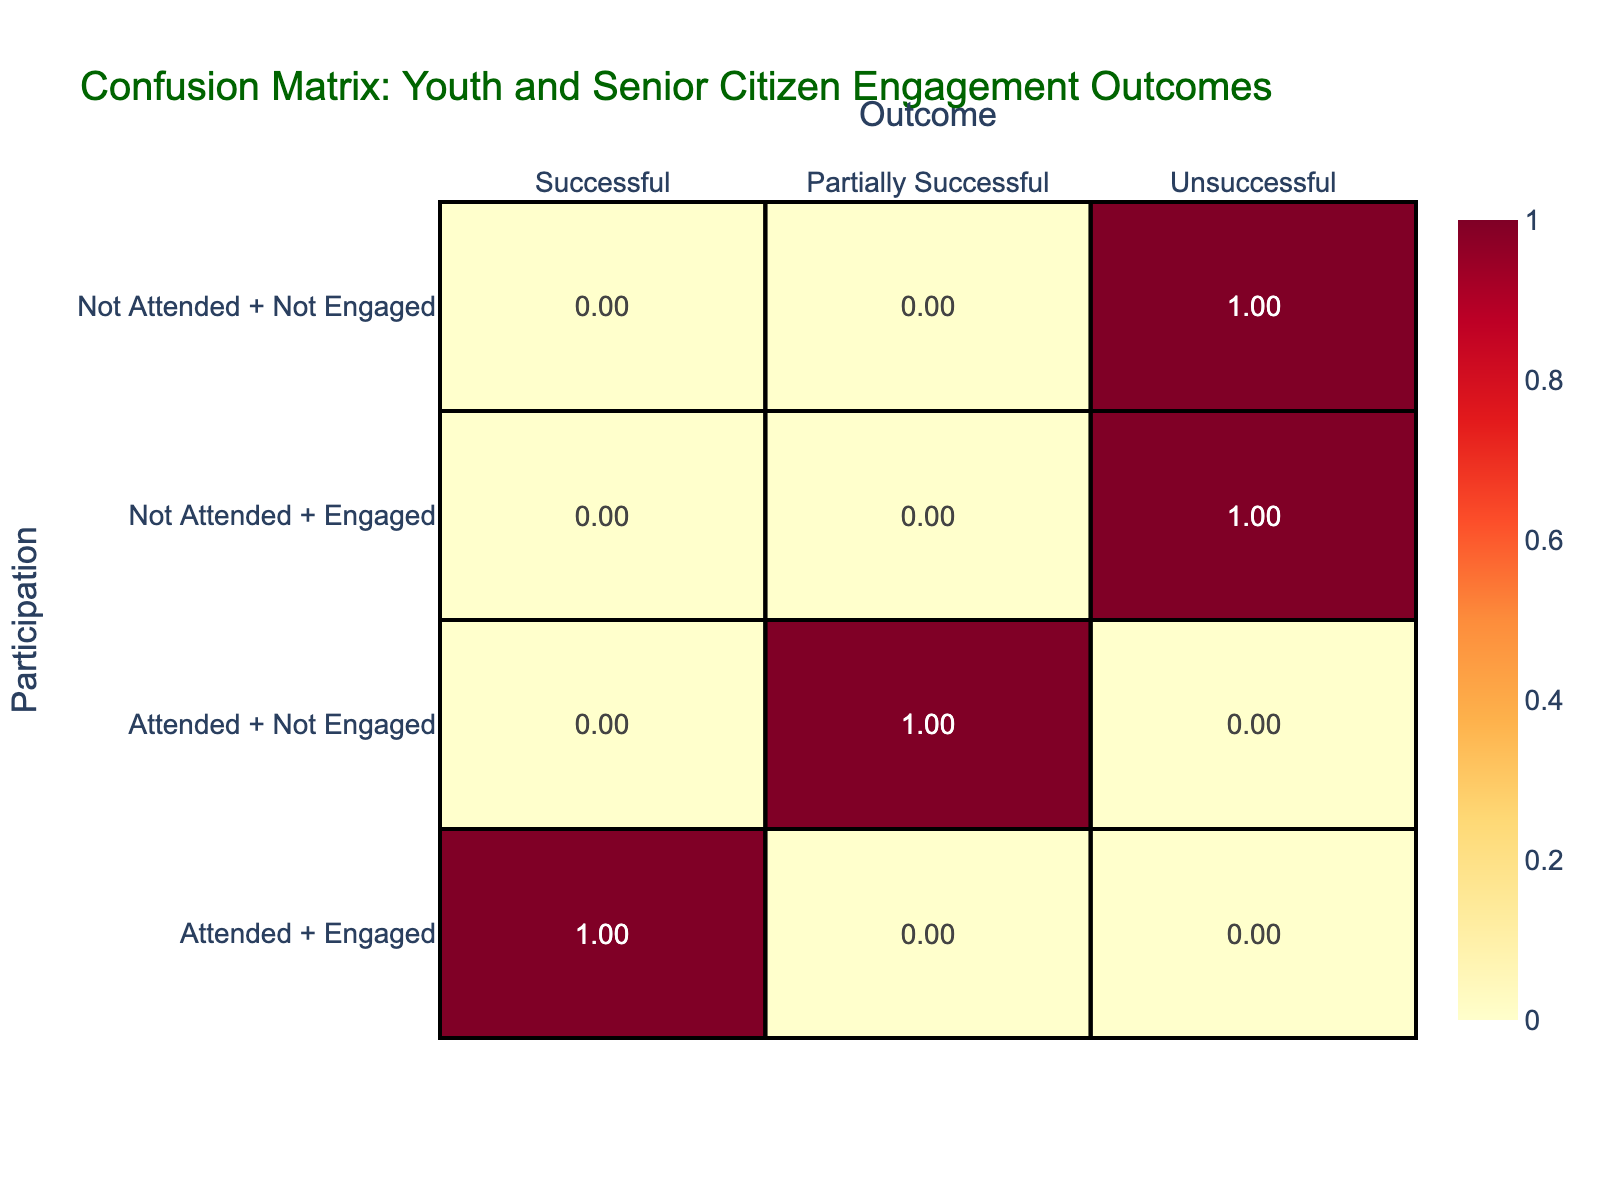What is the percentage of successful outcomes when both youth attended and senior citizens engaged? To find the percentage, we look at the data where youth attended and senior citizens engaged, which occurred 5 times and all resulted in successful outcomes. Since there are 5 outcomes for that participation category out of 5 total occurrences, the percentage is (5/5)*100 = 100%.
Answer: 100% What is the total number of outcomes categorized as unsuccessful? The unsuccessful outcomes appear in two categories: where youth did not attend and senior citizens were not engaged, and where youth did not attend but senior citizens were engaged. Both categories total to 4 outcomes, thus the total number of unsuccessful outcomes is 4.
Answer: 4 How does the percentage of partially successful outcomes compare to successful outcomes when youth attended and senior citizens did not engage? There are 2 outcomes in the partially successful category and none in the successful category for this specific participation type. Therefore, the percentage of partially successful outcomes is (2/2)*100 = 100%, while the percentage of successful outcomes is 0%. Hence, partially successful outcomes are completely represented compared to successful.
Answer: Partially successful outcomes are fully represented Is there any instance where youth did not attend and senior citizens engaged that resulted in a successful outcome? Reviewing the data, in the scenarios where youth did not attend and senior citizens were engaged, it resulted in 2 instances of unsuccessful outcomes. Thus, there are no instances where this scenario led to a successful outcome.
Answer: No What is the difference in successful outcomes between youth who attended and those who did not attend? Youth who attended had 5 successful outcomes, while youth who did not attend had 0 successful outcomes. The difference is calculated by subtracting: 5 (successful outcomes from attendance) - 0 (successful outcomes from not attending) = 5.
Answer: 5 